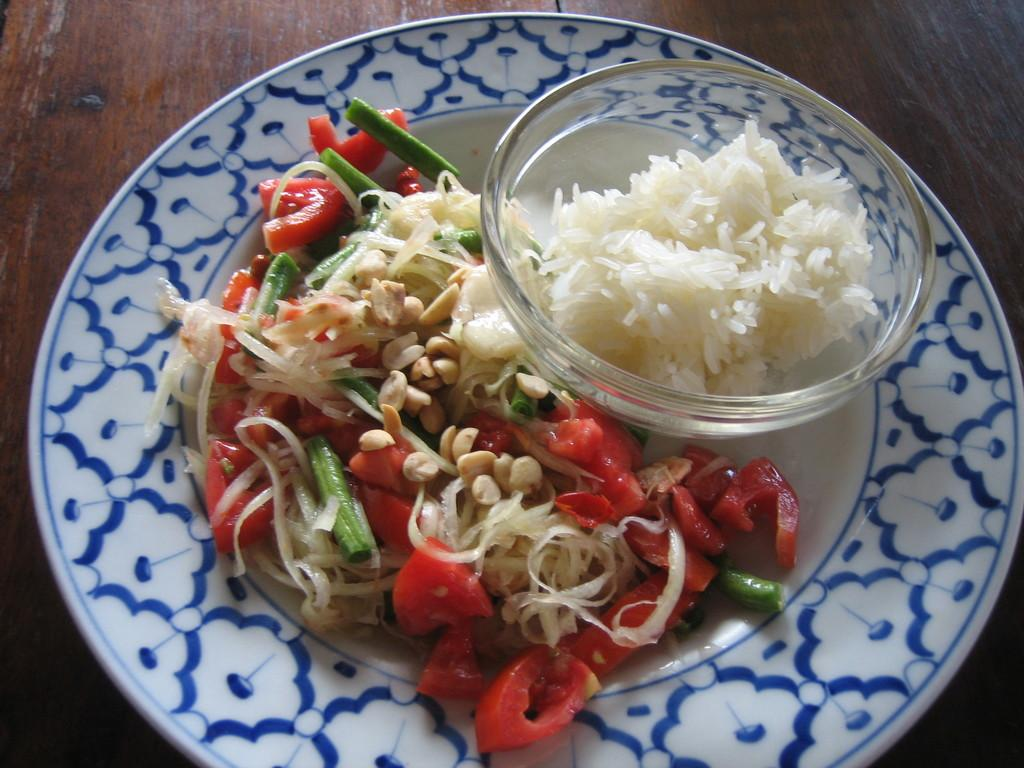What is on the table in the image? There is a plate with food and a bowl with rice on the table. Can you describe the food on the plate? The provided facts do not specify the type of food on the plate. How many dishes are on the table? There are two dishes on the table: a plate with food and a bowl with rice. What letters are visible on the airplane in the image? There is no airplane present in the image. What way is the food arranged on the plate? The provided facts do not specify the arrangement of the food on the plate. 